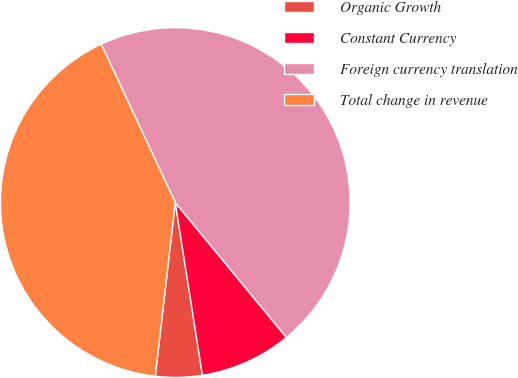<chart> <loc_0><loc_0><loc_500><loc_500><pie_chart><fcel>Organic Growth<fcel>Constant Currency<fcel>Foreign currency translation<fcel>Total change in revenue<nl><fcel>4.31%<fcel>8.48%<fcel>46.0%<fcel>41.21%<nl></chart> 